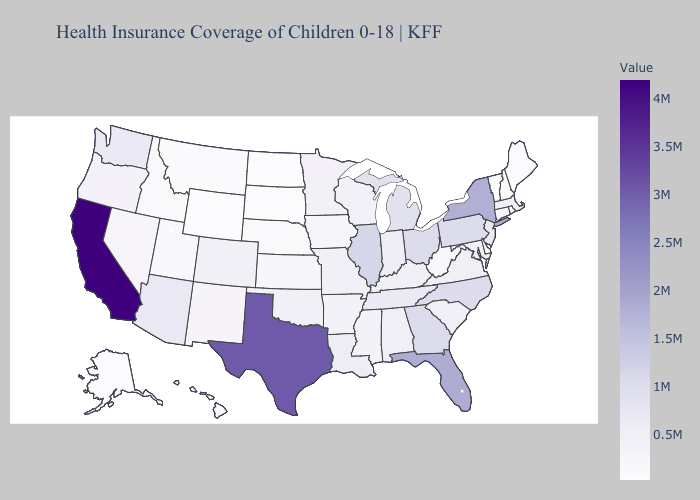Which states hav the highest value in the South?
Answer briefly. Texas. Does Missouri have the highest value in the MidWest?
Keep it brief. No. Does the map have missing data?
Give a very brief answer. No. Does Oklahoma have a higher value than Pennsylvania?
Keep it brief. No. Does Vermont have the lowest value in the Northeast?
Be succinct. Yes. 